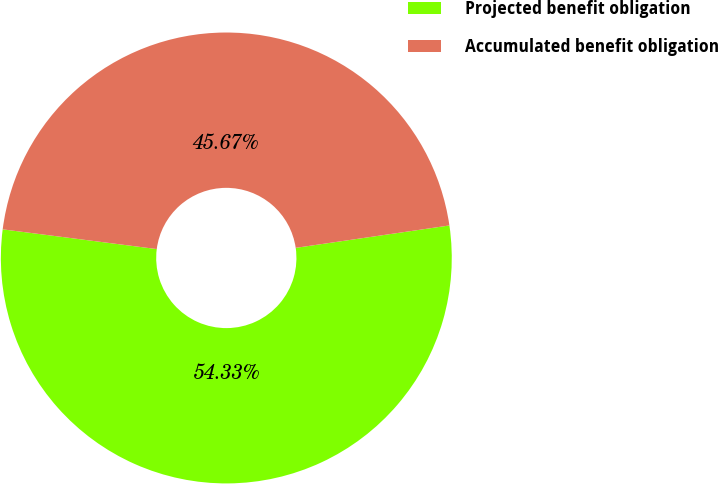Convert chart. <chart><loc_0><loc_0><loc_500><loc_500><pie_chart><fcel>Projected benefit obligation<fcel>Accumulated benefit obligation<nl><fcel>54.33%<fcel>45.67%<nl></chart> 